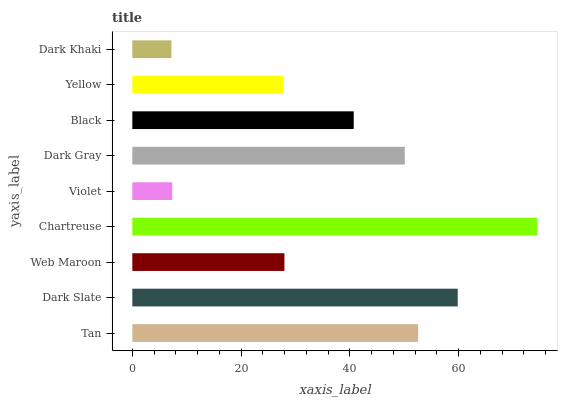Is Dark Khaki the minimum?
Answer yes or no. Yes. Is Chartreuse the maximum?
Answer yes or no. Yes. Is Dark Slate the minimum?
Answer yes or no. No. Is Dark Slate the maximum?
Answer yes or no. No. Is Dark Slate greater than Tan?
Answer yes or no. Yes. Is Tan less than Dark Slate?
Answer yes or no. Yes. Is Tan greater than Dark Slate?
Answer yes or no. No. Is Dark Slate less than Tan?
Answer yes or no. No. Is Black the high median?
Answer yes or no. Yes. Is Black the low median?
Answer yes or no. Yes. Is Dark Gray the high median?
Answer yes or no. No. Is Dark Gray the low median?
Answer yes or no. No. 